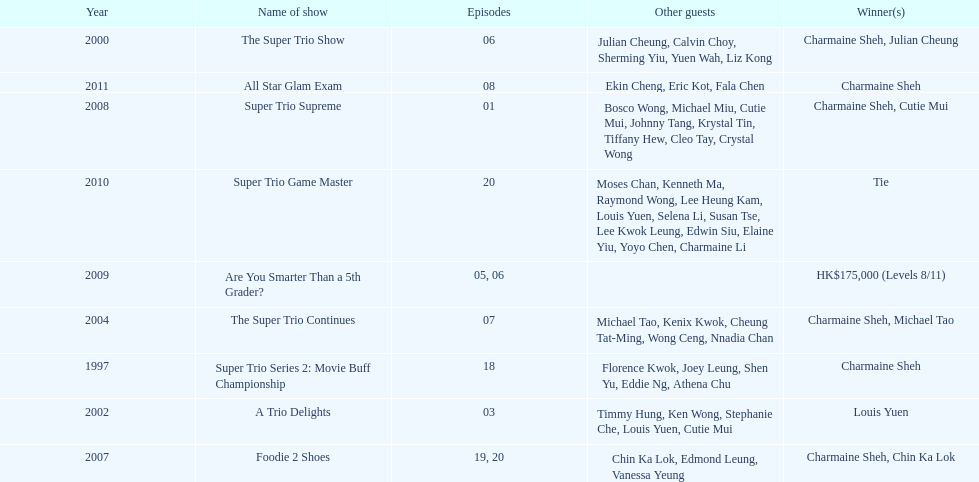What is the duration since charmaine sheh initially made an appearance on a variety show? 17 years. 